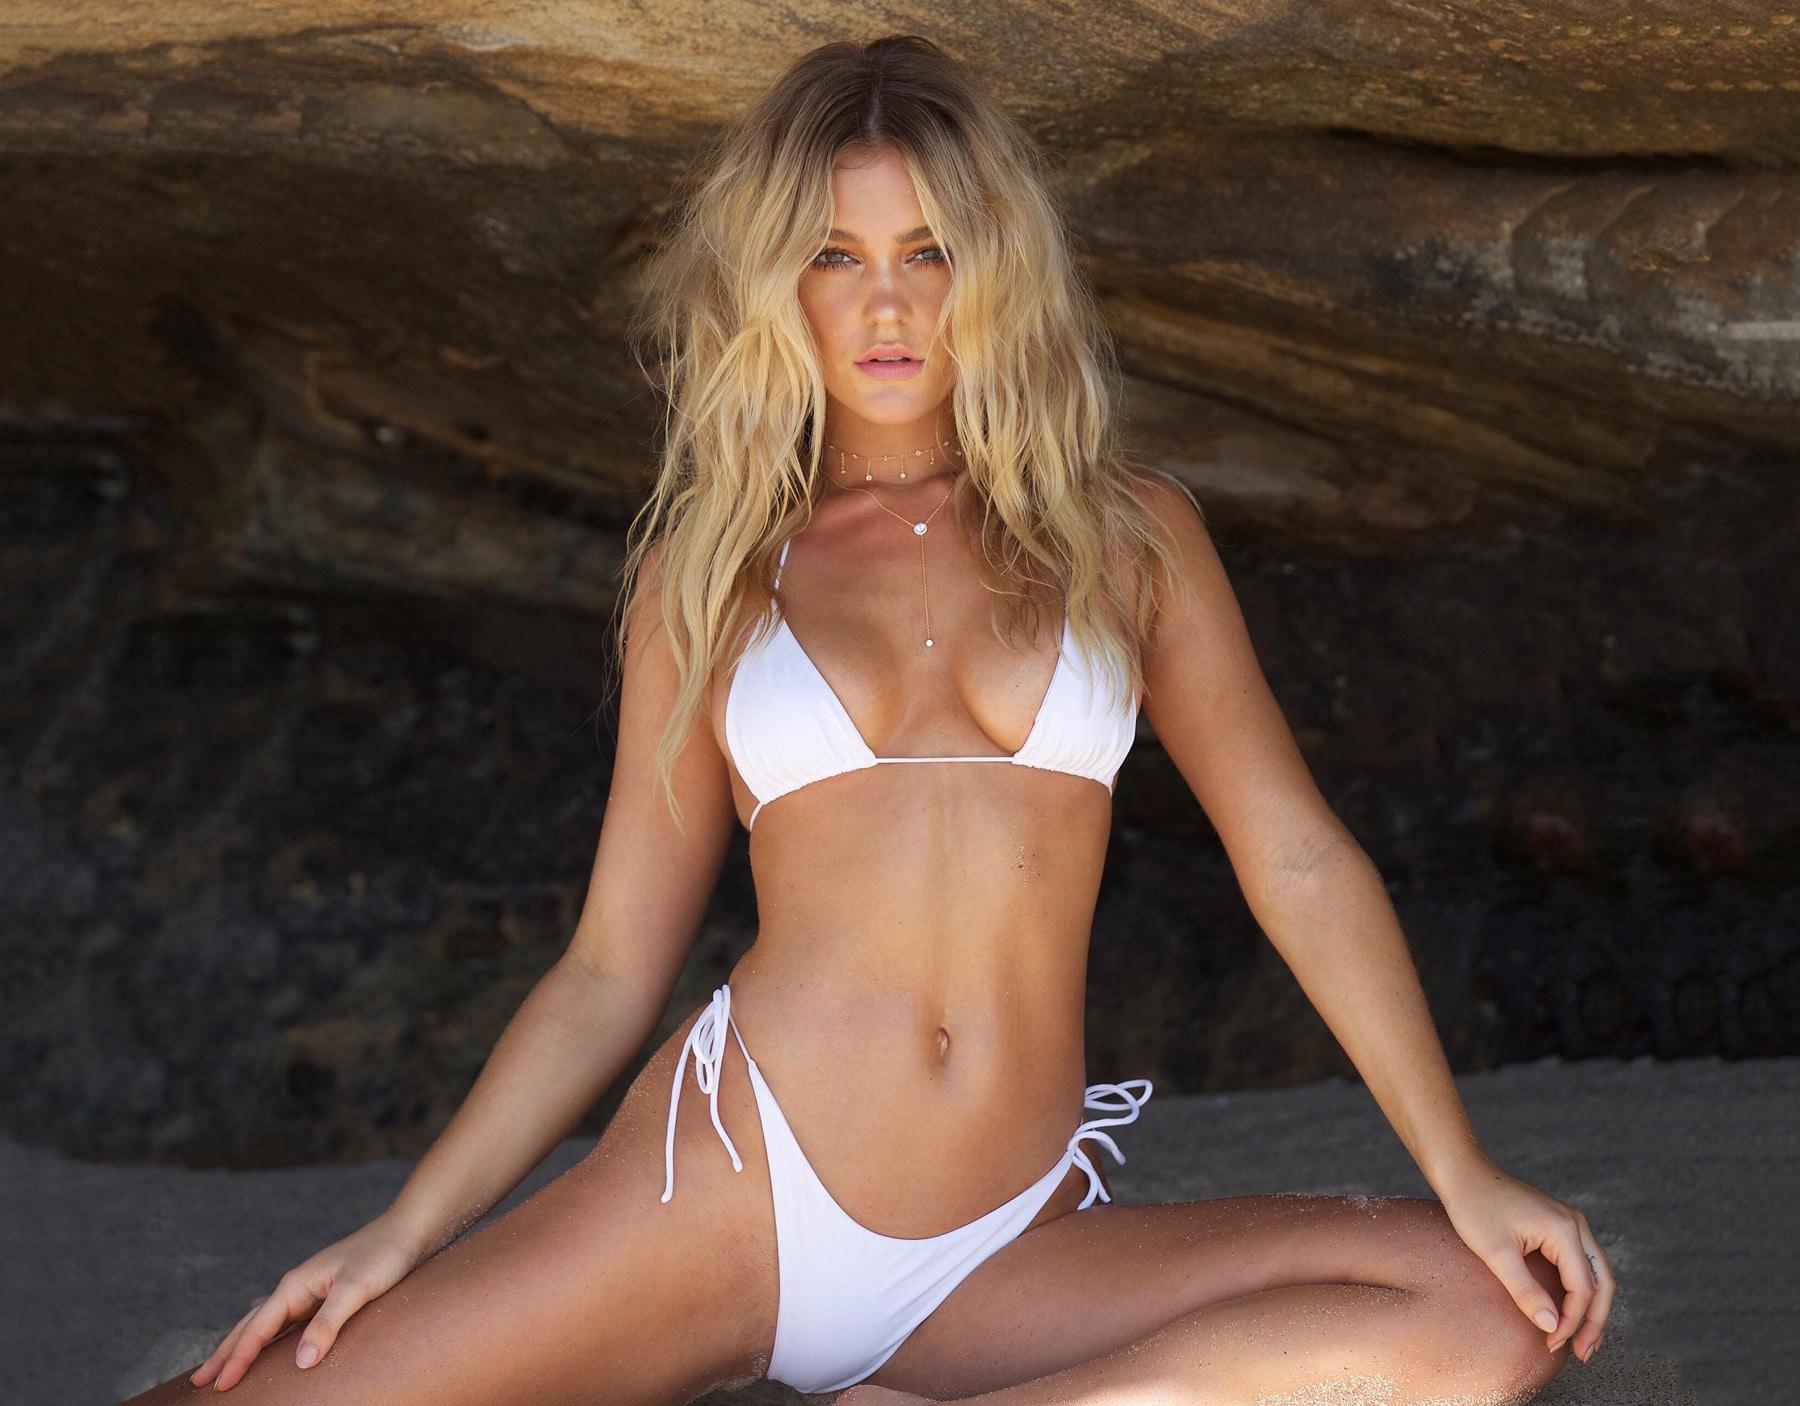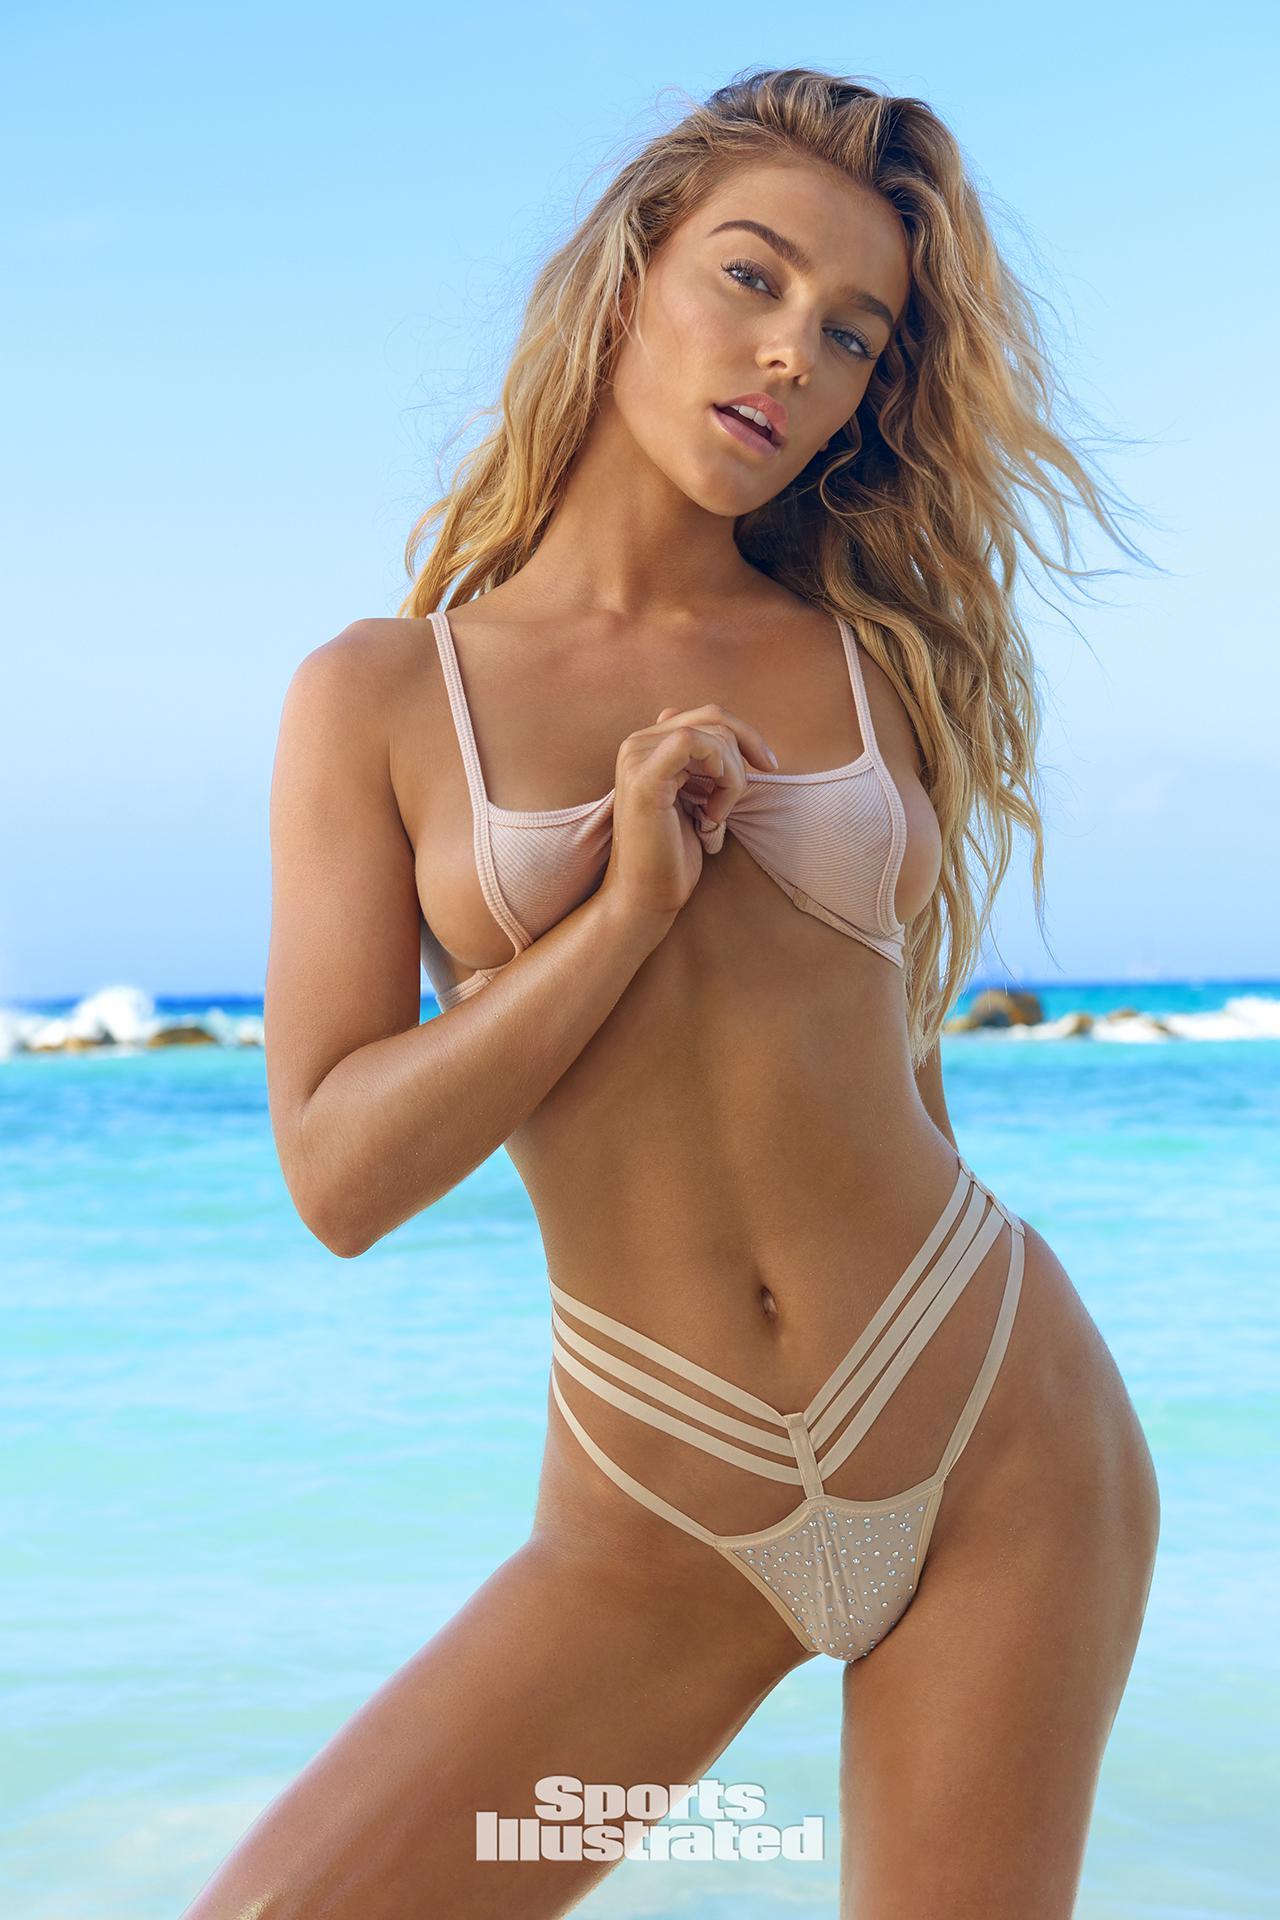The first image is the image on the left, the second image is the image on the right. Examine the images to the left and right. Is the description "A woman is sitting." accurate? Answer yes or no. Yes. 